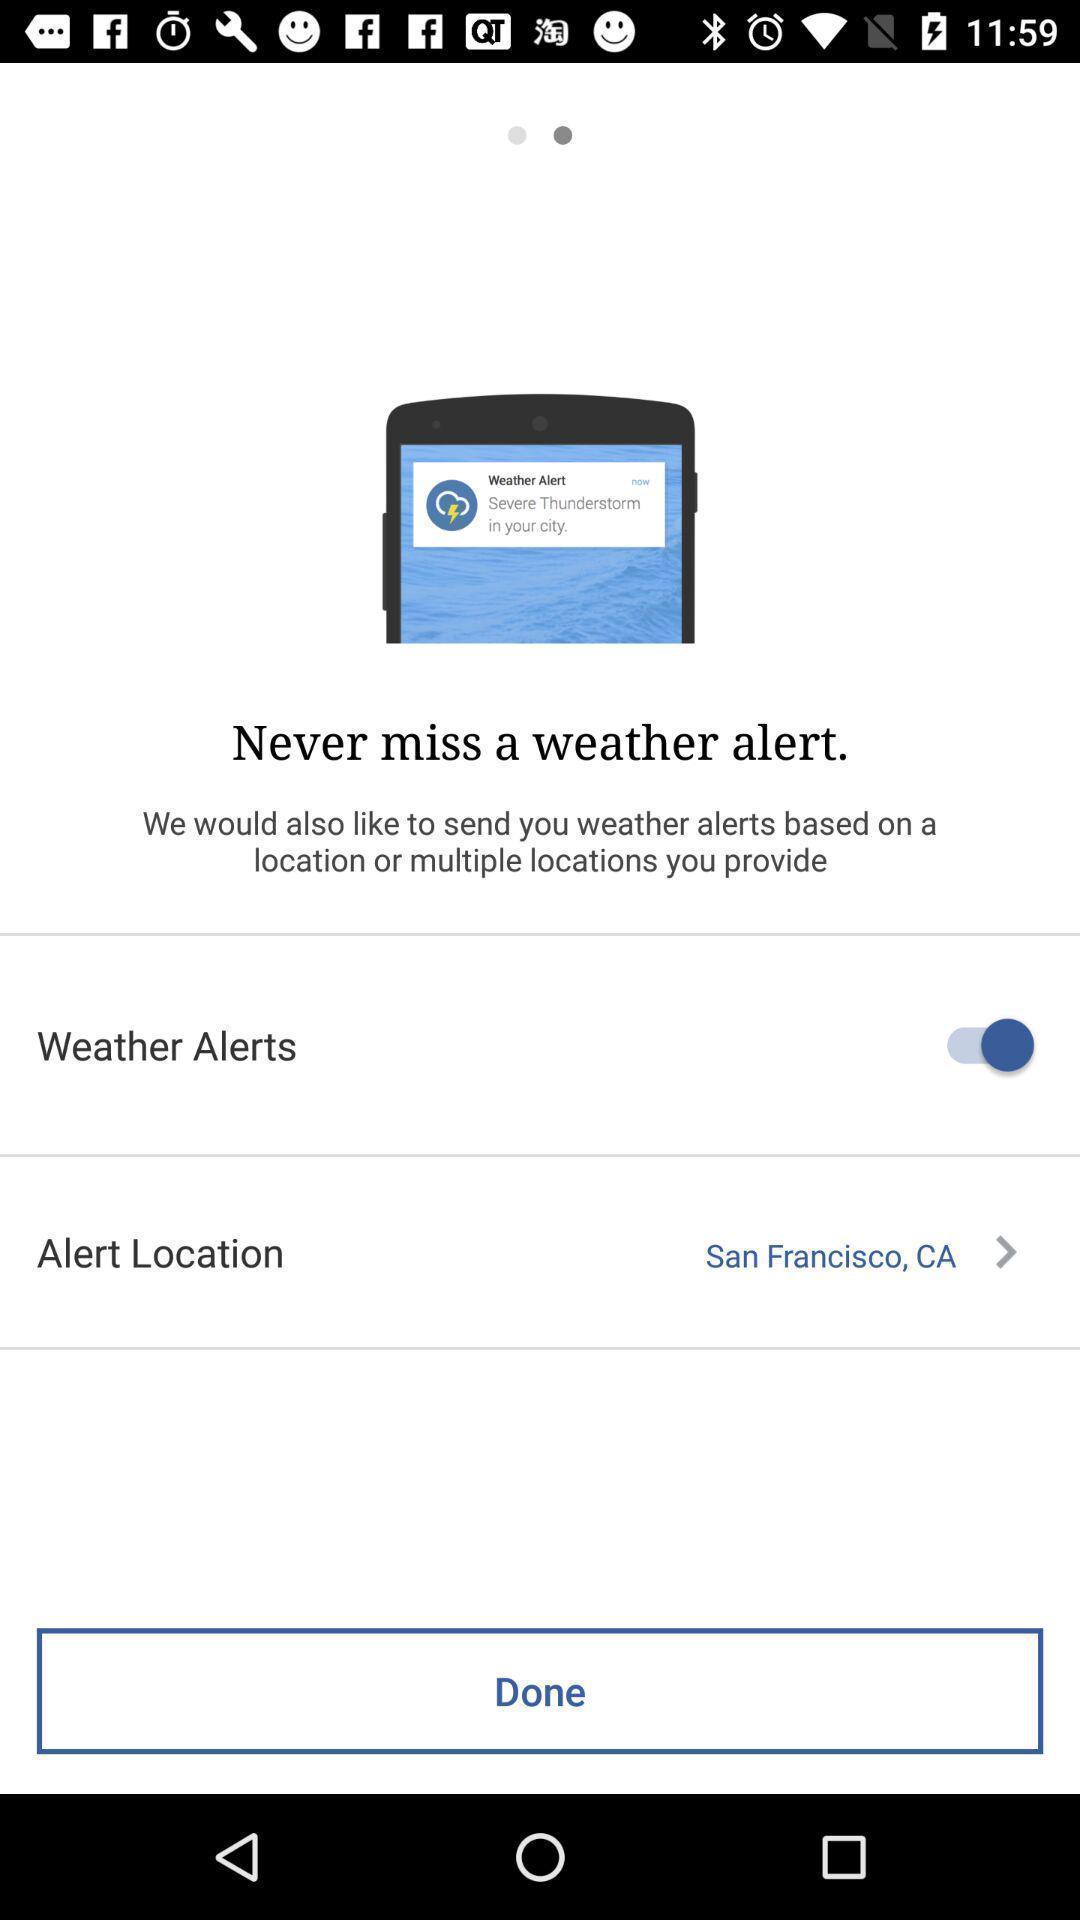Summarize the information in this screenshot. Page for setting weather alerts. 